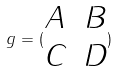<formula> <loc_0><loc_0><loc_500><loc_500>g = ( \begin{matrix} A & B \\ C & D \end{matrix} )</formula> 